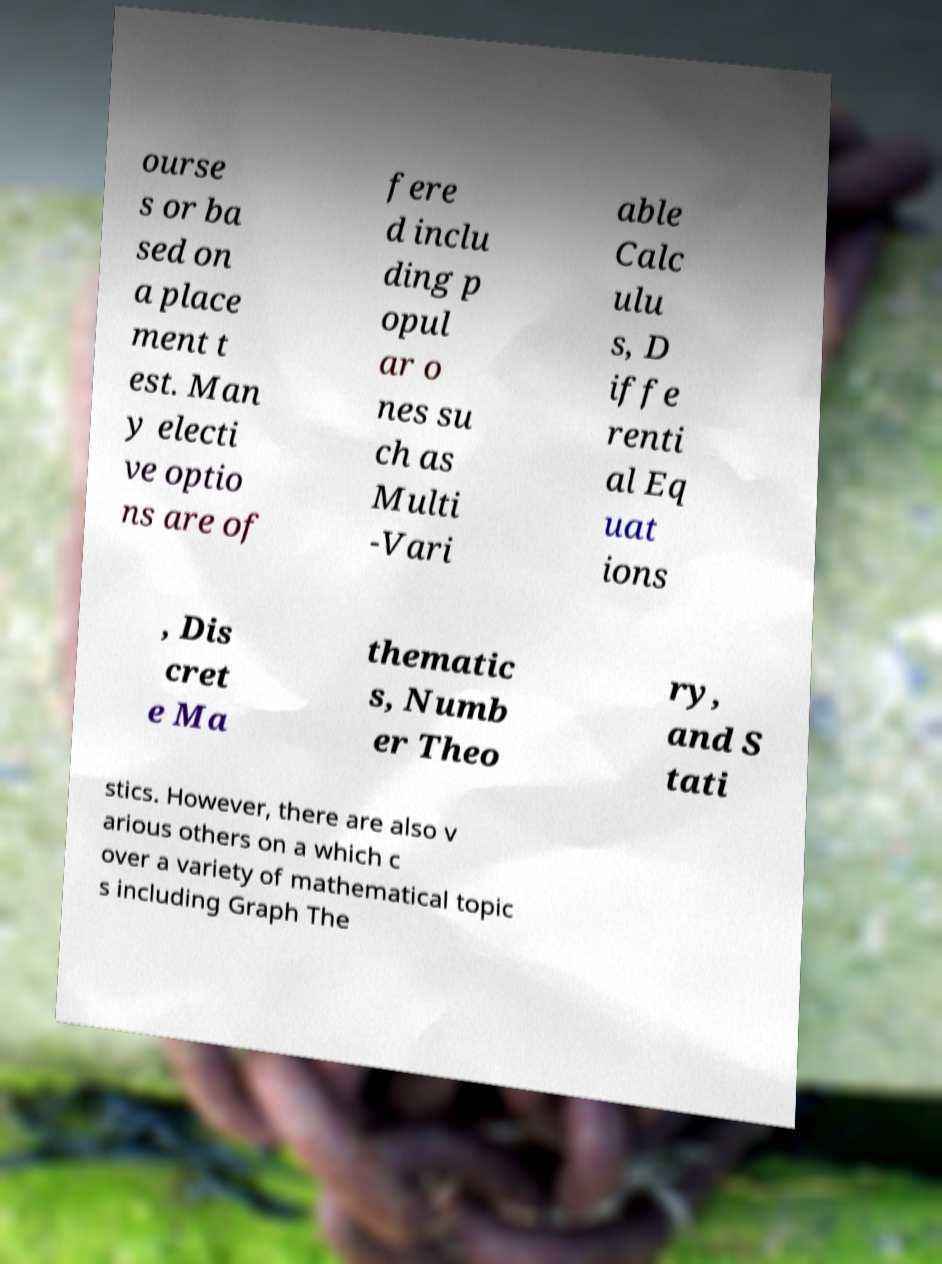Could you assist in decoding the text presented in this image and type it out clearly? ourse s or ba sed on a place ment t est. Man y electi ve optio ns are of fere d inclu ding p opul ar o nes su ch as Multi -Vari able Calc ulu s, D iffe renti al Eq uat ions , Dis cret e Ma thematic s, Numb er Theo ry, and S tati stics. However, there are also v arious others on a which c over a variety of mathematical topic s including Graph The 